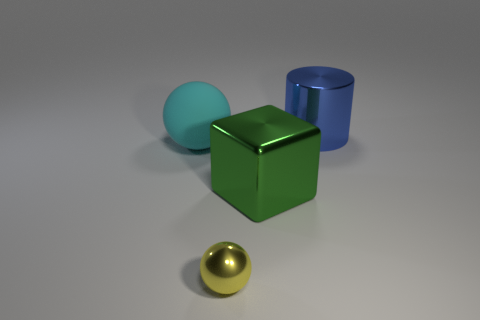Add 3 tiny brown cubes. How many objects exist? 7 Subtract all cylinders. How many objects are left? 3 Add 1 green rubber things. How many green rubber things exist? 1 Subtract 0 cyan cylinders. How many objects are left? 4 Subtract all small gray cubes. Subtract all cubes. How many objects are left? 3 Add 2 yellow metallic spheres. How many yellow metallic spheres are left? 3 